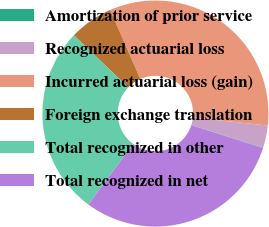Convert chart. <chart><loc_0><loc_0><loc_500><loc_500><pie_chart><fcel>Amortization of prior service<fcel>Recognized actuarial loss<fcel>Incurred actuarial loss (gain)<fcel>Foreign exchange translation<fcel>Total recognized in other<fcel>Total recognized in net<nl><fcel>0.08%<fcel>3.18%<fcel>33.25%<fcel>6.27%<fcel>27.06%<fcel>30.16%<nl></chart> 